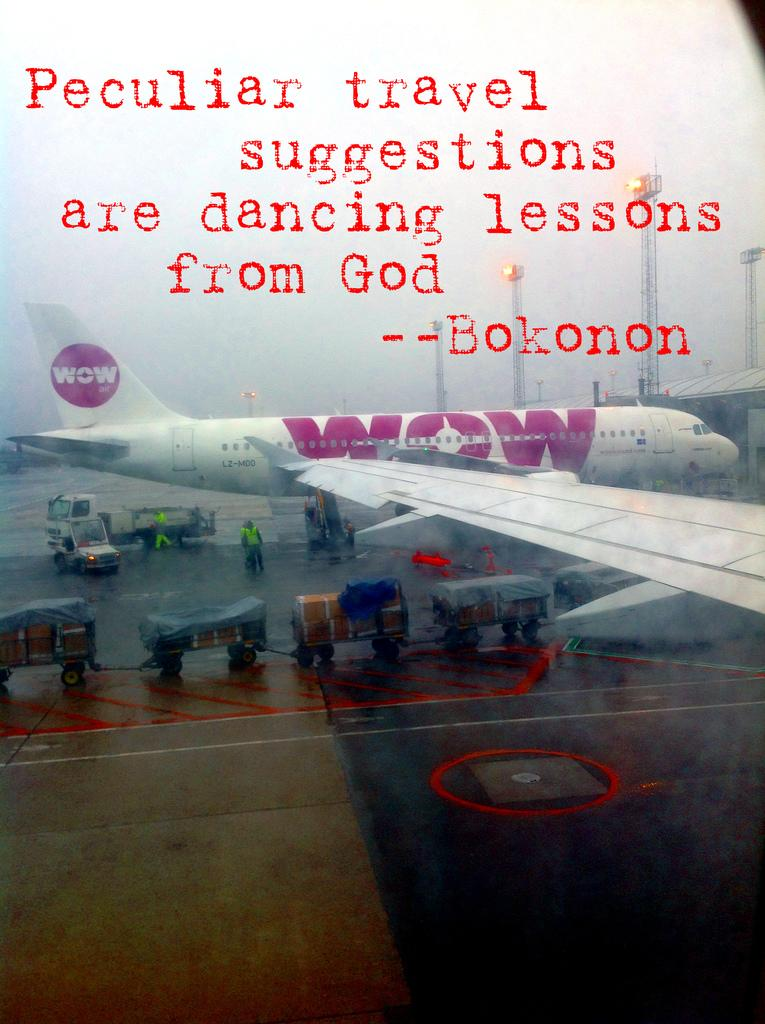<image>
Describe the image concisely. A WOW plane is being loaded with luggage 